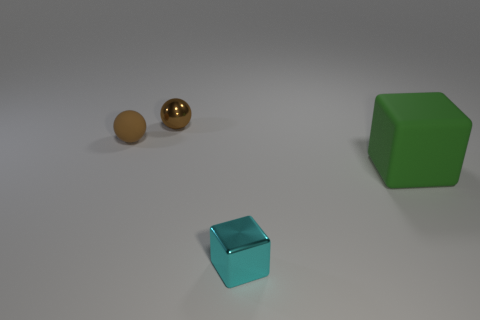Is there any other thing that has the same size as the green rubber block?
Keep it short and to the point. No. What is the color of the shiny cube?
Provide a succinct answer. Cyan. Are there any things in front of the tiny metal object that is behind the brown matte sphere?
Keep it short and to the point. Yes. What shape is the small metal thing that is right of the tiny metallic thing that is behind the tiny brown rubber sphere?
Your response must be concise. Cube. Are there fewer tiny blue cylinders than small cyan metallic cubes?
Ensure brevity in your answer.  Yes. What is the color of the thing that is right of the brown shiny thing and to the left of the big green rubber object?
Offer a very short reply. Cyan. Are there any brown things of the same size as the metallic ball?
Keep it short and to the point. Yes. There is a matte thing to the right of the tiny shiny object that is behind the small cyan shiny object; how big is it?
Keep it short and to the point. Large. Is the number of small blocks to the right of the cyan metallic cube less than the number of red shiny cylinders?
Offer a very short reply. No. Is the color of the tiny matte sphere the same as the small metal sphere?
Make the answer very short. Yes. 